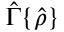Convert formula to latex. <formula><loc_0><loc_0><loc_500><loc_500>\hat { \Gamma } \{ \hat { \rho } \}</formula> 